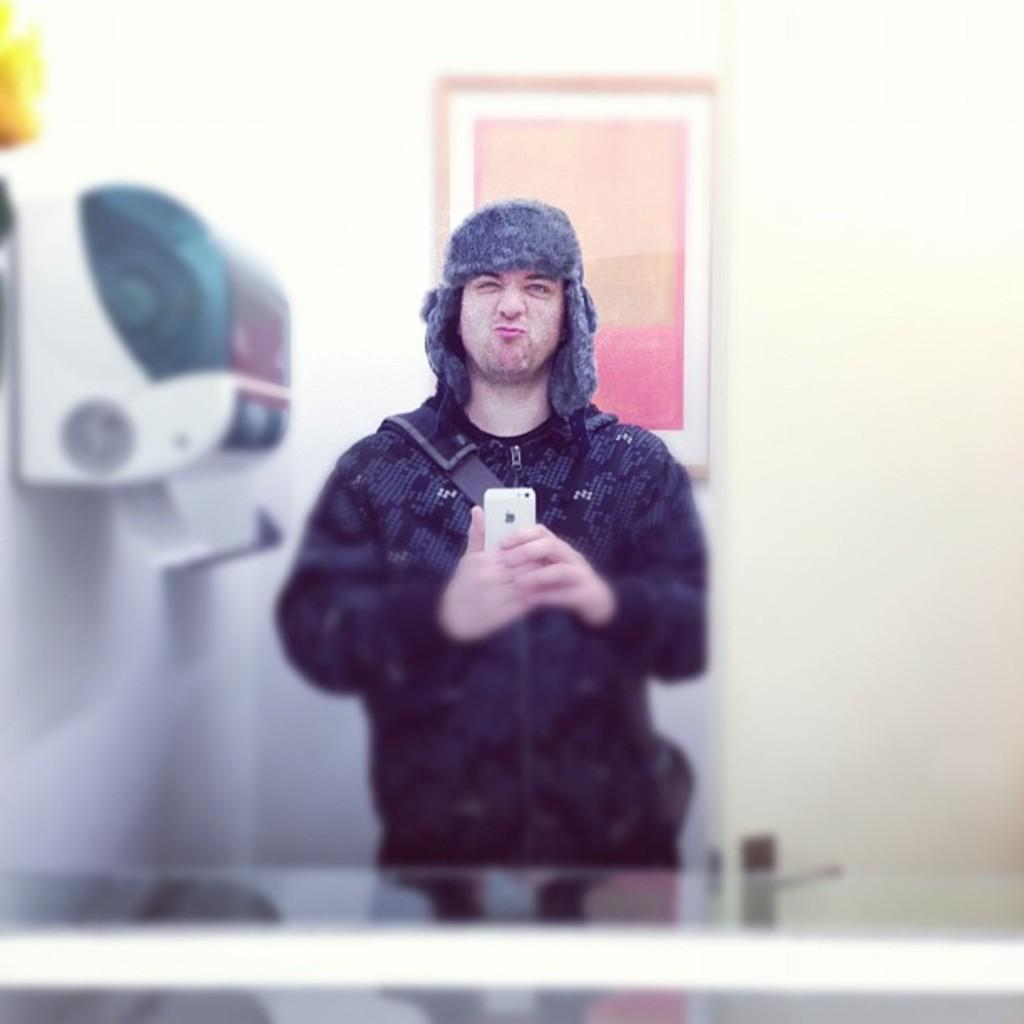What is the person in the image doing? The person is standing in the image. What object is the person holding? The person is holding a cellphone. What can be seen on the wall in the background of the image? There is a frame on the wall in the background of the image. What is located on the wall on the left side of the image? There is an object on the wall on the left side of the image. What type of tax is being discussed in the image? There is no discussion of tax in the image; it features a person standing and holding a cellphone. Where is the park located in the image? There is no park present in the image. 